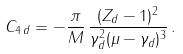<formula> <loc_0><loc_0><loc_500><loc_500>C _ { 4 \, d } = - \frac { \pi } { M } \, \frac { ( Z _ { d } - 1 ) ^ { 2 } } { \gamma ^ { 2 } _ { d } ( \mu - \gamma _ { d } ) ^ { 3 } } \, .</formula> 